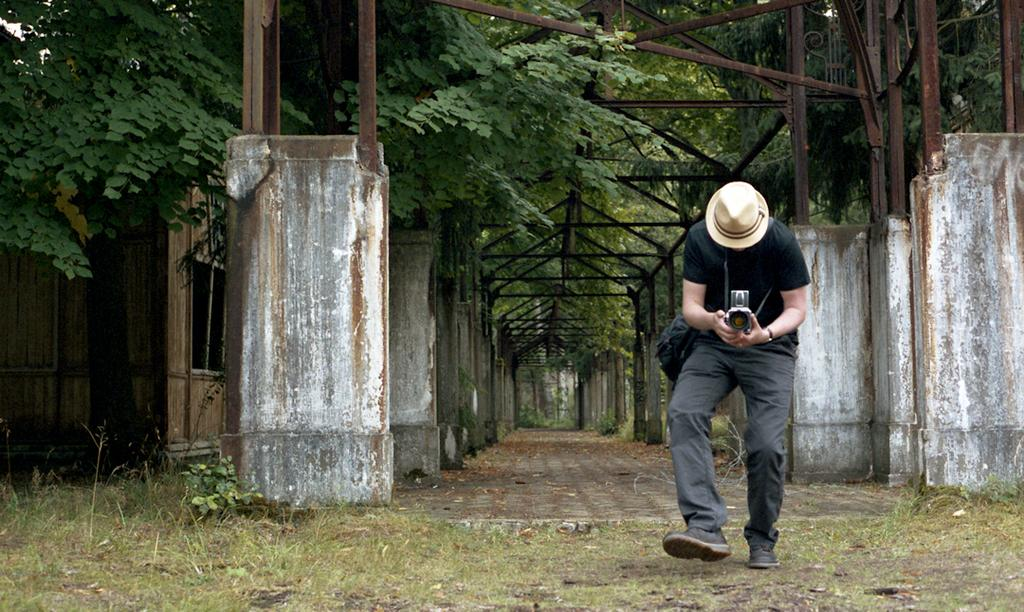What is the person in the image doing? The person in the image is standing and holding a camera. What structures can be seen in the image? There are pillars with iron rods in the image. What type of vegetation is present in the image? There are plants and trees in the image. What type of building is depicted in the image? The image appears to depict a shed. What type of agreement is being signed by the squirrel in the image? There is no squirrel present in the image, and therefore no agreement can be signed. 